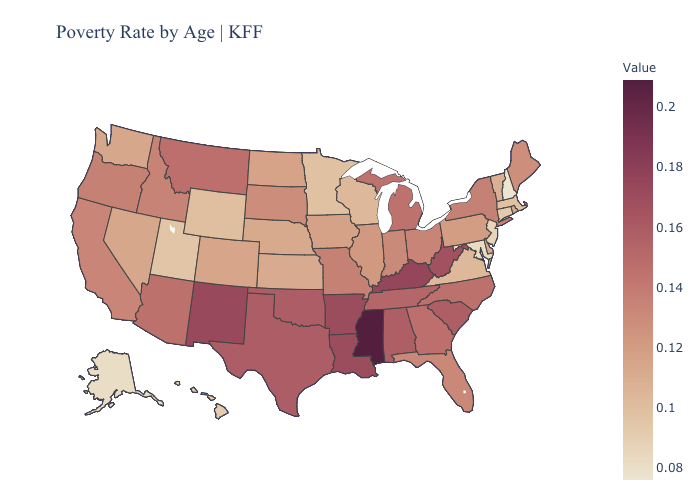Does New Hampshire have the lowest value in the USA?
Concise answer only. Yes. 